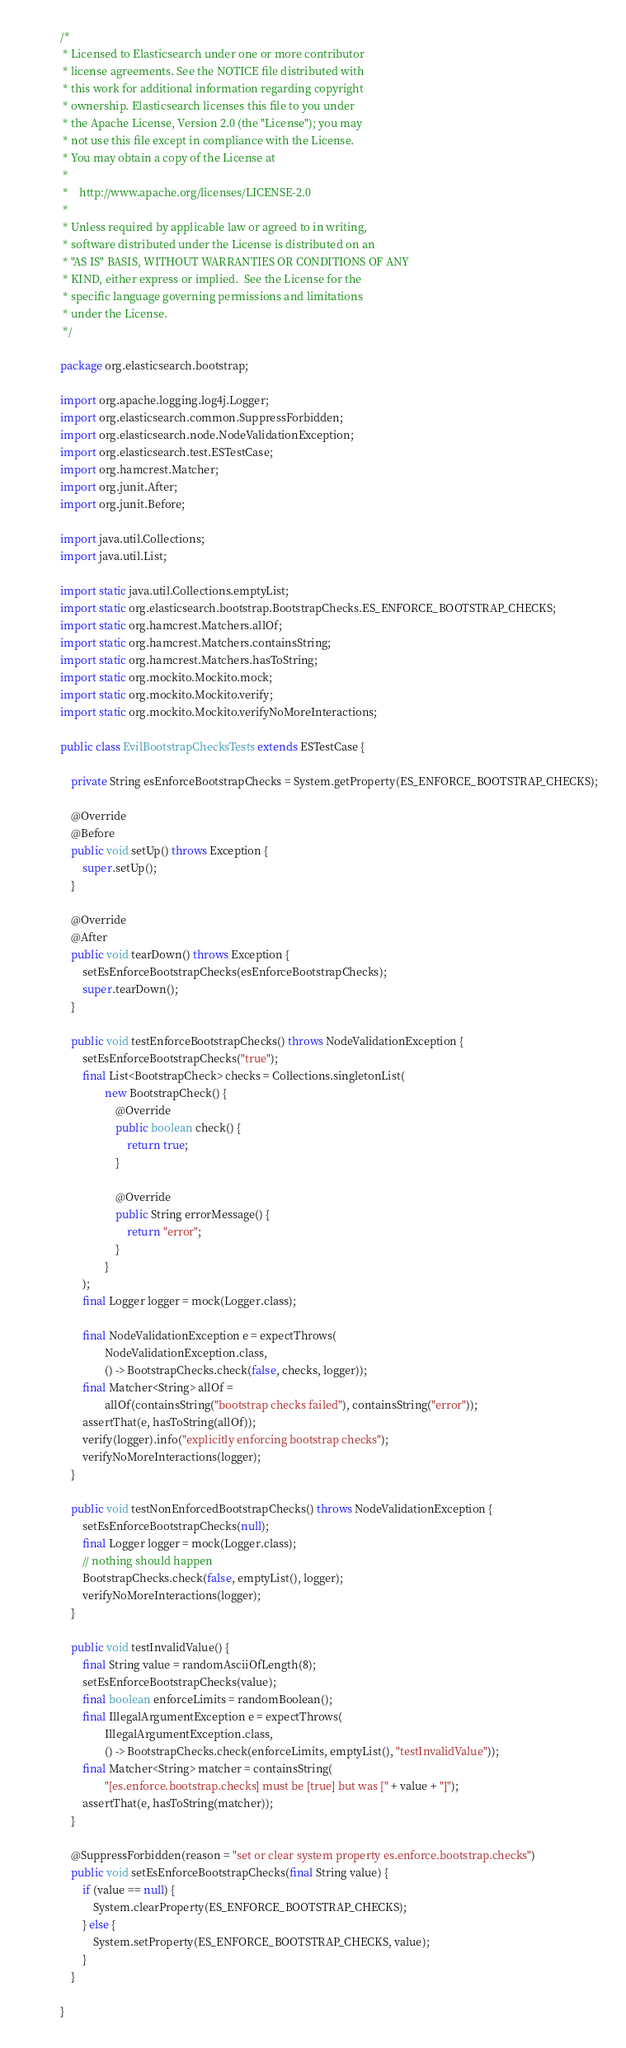<code> <loc_0><loc_0><loc_500><loc_500><_Java_>/*
 * Licensed to Elasticsearch under one or more contributor
 * license agreements. See the NOTICE file distributed with
 * this work for additional information regarding copyright
 * ownership. Elasticsearch licenses this file to you under
 * the Apache License, Version 2.0 (the "License"); you may
 * not use this file except in compliance with the License.
 * You may obtain a copy of the License at
 *
 *    http://www.apache.org/licenses/LICENSE-2.0
 *
 * Unless required by applicable law or agreed to in writing,
 * software distributed under the License is distributed on an
 * "AS IS" BASIS, WITHOUT WARRANTIES OR CONDITIONS OF ANY
 * KIND, either express or implied.  See the License for the
 * specific language governing permissions and limitations
 * under the License.
 */

package org.elasticsearch.bootstrap;

import org.apache.logging.log4j.Logger;
import org.elasticsearch.common.SuppressForbidden;
import org.elasticsearch.node.NodeValidationException;
import org.elasticsearch.test.ESTestCase;
import org.hamcrest.Matcher;
import org.junit.After;
import org.junit.Before;

import java.util.Collections;
import java.util.List;

import static java.util.Collections.emptyList;
import static org.elasticsearch.bootstrap.BootstrapChecks.ES_ENFORCE_BOOTSTRAP_CHECKS;
import static org.hamcrest.Matchers.allOf;
import static org.hamcrest.Matchers.containsString;
import static org.hamcrest.Matchers.hasToString;
import static org.mockito.Mockito.mock;
import static org.mockito.Mockito.verify;
import static org.mockito.Mockito.verifyNoMoreInteractions;

public class EvilBootstrapChecksTests extends ESTestCase {

    private String esEnforceBootstrapChecks = System.getProperty(ES_ENFORCE_BOOTSTRAP_CHECKS);

    @Override
    @Before
    public void setUp() throws Exception {
        super.setUp();
    }

    @Override
    @After
    public void tearDown() throws Exception {
        setEsEnforceBootstrapChecks(esEnforceBootstrapChecks);
        super.tearDown();
    }

    public void testEnforceBootstrapChecks() throws NodeValidationException {
        setEsEnforceBootstrapChecks("true");
        final List<BootstrapCheck> checks = Collections.singletonList(
                new BootstrapCheck() {
                    @Override
                    public boolean check() {
                        return true;
                    }

                    @Override
                    public String errorMessage() {
                        return "error";
                    }
                }
        );
        final Logger logger = mock(Logger.class);

        final NodeValidationException e = expectThrows(
                NodeValidationException.class,
                () -> BootstrapChecks.check(false, checks, logger));
        final Matcher<String> allOf =
                allOf(containsString("bootstrap checks failed"), containsString("error"));
        assertThat(e, hasToString(allOf));
        verify(logger).info("explicitly enforcing bootstrap checks");
        verifyNoMoreInteractions(logger);
    }

    public void testNonEnforcedBootstrapChecks() throws NodeValidationException {
        setEsEnforceBootstrapChecks(null);
        final Logger logger = mock(Logger.class);
        // nothing should happen
        BootstrapChecks.check(false, emptyList(), logger);
        verifyNoMoreInteractions(logger);
    }

    public void testInvalidValue() {
        final String value = randomAsciiOfLength(8);
        setEsEnforceBootstrapChecks(value);
        final boolean enforceLimits = randomBoolean();
        final IllegalArgumentException e = expectThrows(
                IllegalArgumentException.class,
                () -> BootstrapChecks.check(enforceLimits, emptyList(), "testInvalidValue"));
        final Matcher<String> matcher = containsString(
                "[es.enforce.bootstrap.checks] must be [true] but was [" + value + "]");
        assertThat(e, hasToString(matcher));
    }

    @SuppressForbidden(reason = "set or clear system property es.enforce.bootstrap.checks")
    public void setEsEnforceBootstrapChecks(final String value) {
        if (value == null) {
            System.clearProperty(ES_ENFORCE_BOOTSTRAP_CHECKS);
        } else {
            System.setProperty(ES_ENFORCE_BOOTSTRAP_CHECKS, value);
        }
    }

}
</code> 